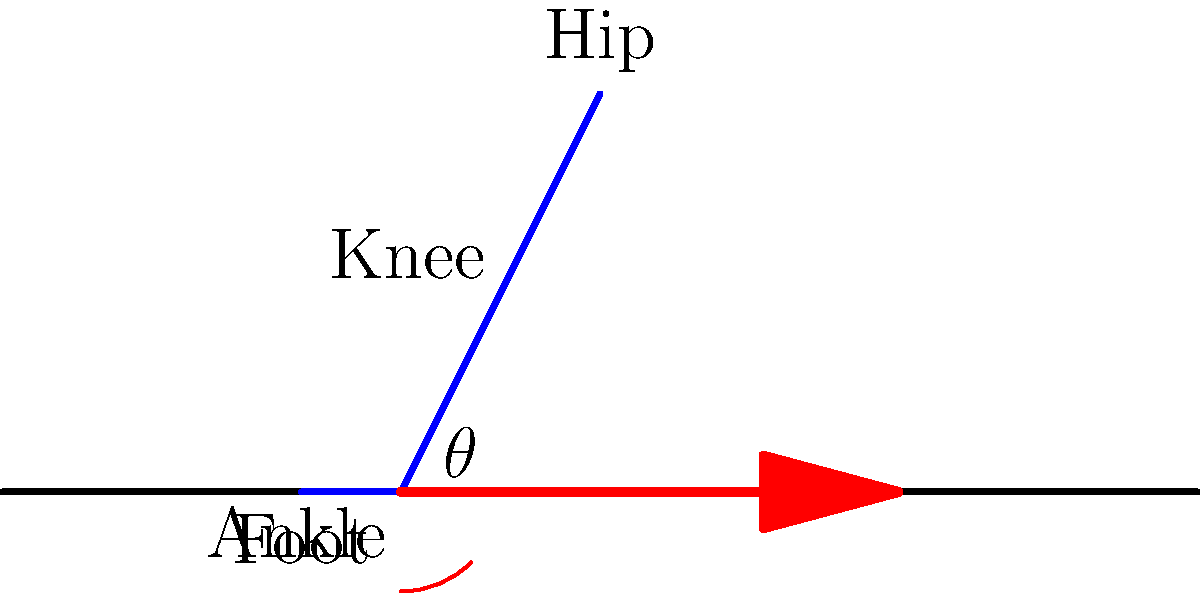In the diagram, the leg is positioned for a football kick-off. What is the optimal angle $\theta$ between the ground and the kicking leg for maximum distance, assuming ideal conditions? To determine the optimal angle for a football kick-off, we need to consider the principles of projectile motion:

1. The range of a projectile is given by the equation:
   $$R = \frac{v^2 \sin(2\theta)}{g}$$
   where $R$ is the range, $v$ is the initial velocity, $\theta$ is the launch angle, and $g$ is the acceleration due to gravity.

2. To find the maximum range, we need to maximize $\sin(2\theta)$.

3. The maximum value of $\sin(2\theta)$ occurs when $2\theta = 90°$.

4. Solving for $\theta$:
   $$2\theta = 90°$$
   $$\theta = 45°$$

5. In real-world conditions, factors like air resistance and the shape of the football slightly reduce this angle.

6. Empirical studies and practical experience in American football suggest that the optimal angle for maximum distance is typically between 40° and 45°.

Therefore, the optimal angle $\theta$ for a football kick-off to achieve maximum distance, assuming ideal conditions, is approximately 45°.
Answer: 45° 